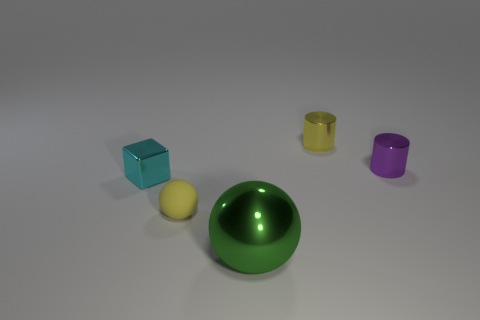Add 5 tiny cyan metal objects. How many objects exist? 10 Subtract all blocks. How many objects are left? 4 Subtract 0 gray spheres. How many objects are left? 5 Subtract all purple rubber things. Subtract all cyan blocks. How many objects are left? 4 Add 3 cyan blocks. How many cyan blocks are left? 4 Add 1 tiny yellow things. How many tiny yellow things exist? 3 